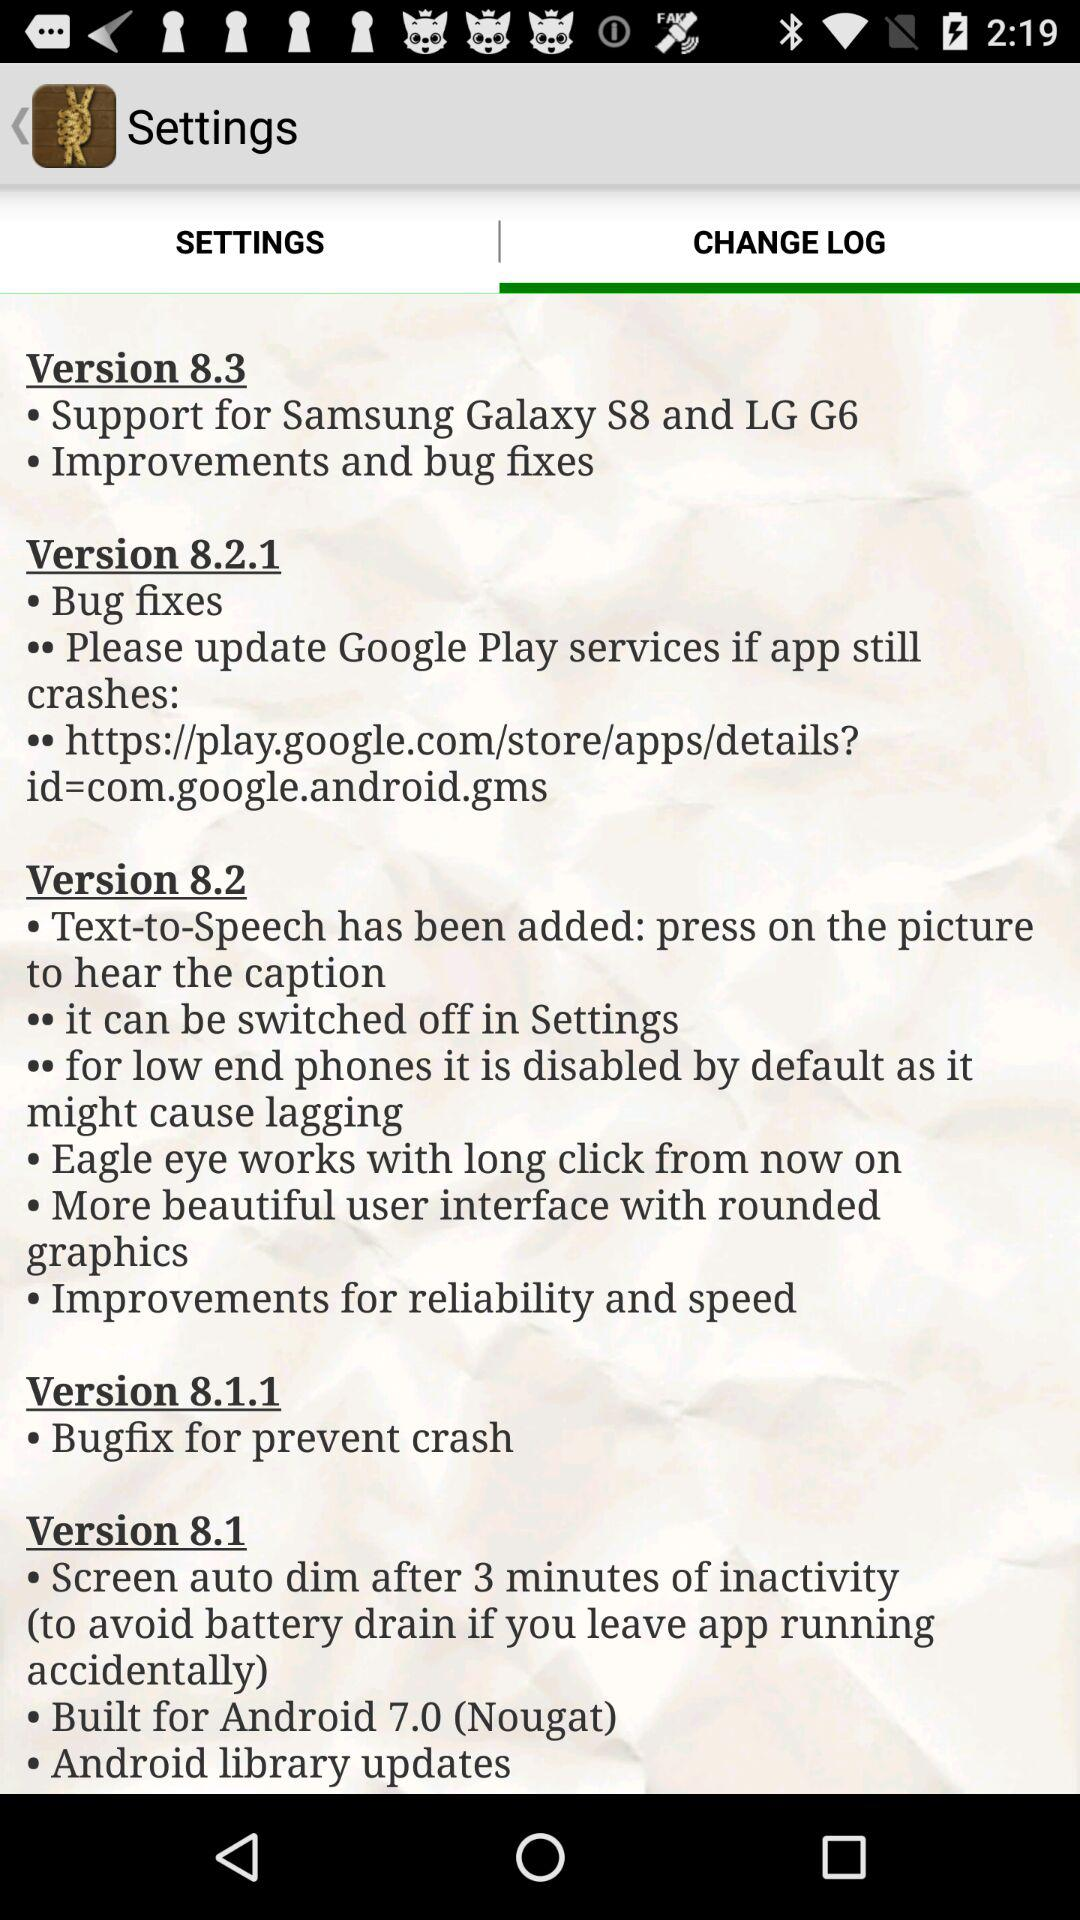In which version is the "Bugfix for prevent crash"? The "Bugfix for prevent crash" is in version 8.1.1. 